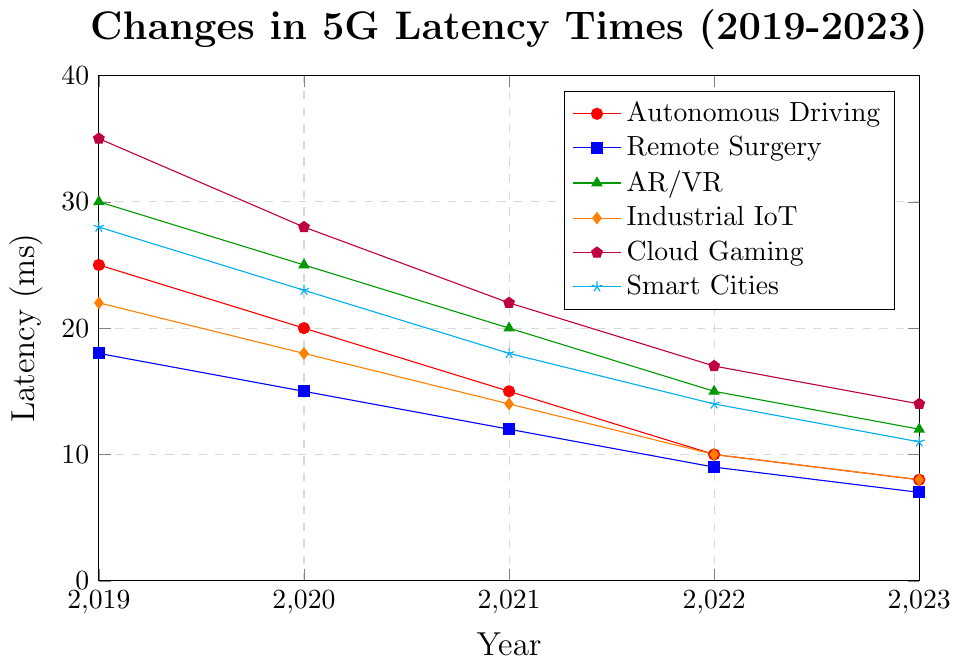Which application had the highest latency in 2019? The highest point in 2019 is associated with the application that has the tallest peak on the leftmost (2019) vertical line. According to the figure, Cloud Gaming has a latency of 35 ms, which is the highest.
Answer: Cloud Gaming How did the latency times for Remote Surgery and AR/VR compare in 2023? To compare their latencies, observe the points on the far-right (2023) for both lines labeled "Remote Surgery" and "AR/VR". Remote Surgery is at 7 ms, whereas AR/VR is at 12 ms.
Answer: Remote Surgery had lower latency than AR/VR in 2023 What is the average latency of Autonomous Driving from 2019 to 2023? Add the latency values from 2019, 2020, 2021, 2022, and 2023 for Autonomous Driving and divide by the number of years: (25 + 20 + 15 + 10 + 8)/5 = 15.6 ms
Answer: 15.6 ms Which application experienced the greatest decrease in latency from 2019 to 2023? Calculate the difference between latencies in 2019 and 2023 for each application. The differences are: Autonomous Driving (25-8=17), Remote Surgery (18-7=11), AR/VR (30-12=18), Industrial IoT (22-8=14), Cloud Gaming (35-14=21), and Smart Cities (28-11=17). Cloud Gaming experienced the greatest decrease (21 ms).
Answer: Cloud Gaming Were there any applications with the same latency in 2022? To find equal latencies, look for overlapping points on the 2022 vertical line. Autonomous Driving and Industrial IoT both have a latency of 10 ms in 2022.
Answer: Yes, Autonomous Driving and Industrial IoT By how much did the latency decrease for Smart Cities from 2019 to 2022? Subtract the 2022 latency value from the 2019 latency value for Smart Cities: 28 - 14 = 14 ms.
Answer: 14 ms What is the median latency value for AR/VR across the years provided? Arrange the values for AR/VR (30, 25, 20, 15, 12) in ascending order, then find the middle value: (12, 15, 20, 25, 30). The median value is 20 ms.
Answer: 20 ms Between which consecutive years did Cloud Gaming see the largest decrease in latency? Calculate the annual decreases and identify the largest: (35-28=7), (28-22=6), (22-17=5), (17-14=3). The largest decrease is from 2019 to 2020, which is 7 ms.
Answer: 2019 to 2020 